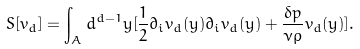<formula> <loc_0><loc_0><loc_500><loc_500>S [ v _ { d } ] = \int _ { A } d ^ { d - 1 } y [ \frac { 1 } { 2 } \partial _ { i } v _ { d } ( y ) \partial _ { i } v _ { d } ( y ) + \frac { \delta p } { \nu \rho } v _ { d } ( y ) ] .</formula> 